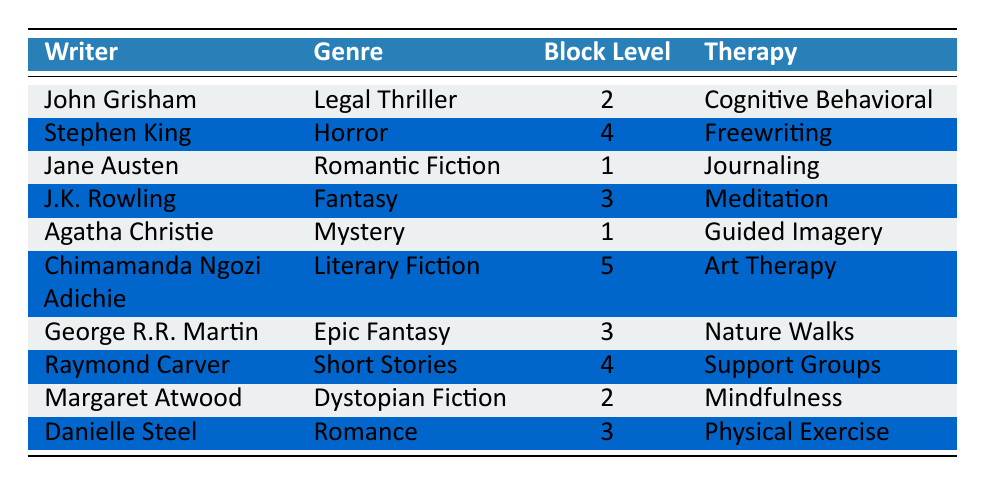What genre does J.K. Rowling prefer? According to the table, J.K. Rowling is associated with the preferred genre of Fantasy.
Answer: Fantasy What therapy does Raymond Carver use? The table indicates that Raymond Carver uses Support Groups as his type of therapy.
Answer: Support Groups Who has the highest writer block level? By examining the writer block levels listed, Chimamanda Ngozi Adichie has the highest level at 5.
Answer: Chimamanda Ngozi Adichie What is the average writer block level of the writers who prefer Romance? The writers who prefer Romance are J.K. Rowling (writer block level 3) and Danielle Steel (writer block level 3). The average is (3 + 3) / 2 = 3.
Answer: 3 Is Jane Austen's writer block level higher than John Grisham's? Jane Austen has a writer block level of 1, while John Grisham's writer block level is 2. Hence, it is false that Jane Austen's level is higher.
Answer: No Which therapy type is most commonly used among writers with a writer block level of 3? The writers with a block level of 3 are J.K. Rowling (Meditation), George R.R. Martin (Nature Walks), and Danielle Steel (Physical Exercise). Each uses a different type of therapy, so no therapy type is most common.
Answer: None How many writers prefer genres that are categorized as fiction? The genres categorized as fiction are Romantic Fiction (Jane Austen), Literary Fiction (Chimamanda Ngozi Adichie), Dystopian Fiction (Margaret Atwood), and Romance (Danielle Steel), totaling 4 writers.
Answer: 4 What is the difference in writer block levels between the lowest and highest levels? The lowest writer block level is 1 (Jane Austen and Agatha Christie) and the highest is 5 (Chimamanda Ngozi Adichie). Thus, the difference is 5 - 1 = 4.
Answer: 4 Which writer prefers Mystery and what is their block level? Agatha Christie prefers the genre of Mystery and has a writer block level of 1.
Answer: Agatha Christie, 1 Does any writer prefer a genre associated with Horror? Yes, Stephen King is the writer who prefers the genre of Horror, confirming the presence of this genre in the table.
Answer: Yes 